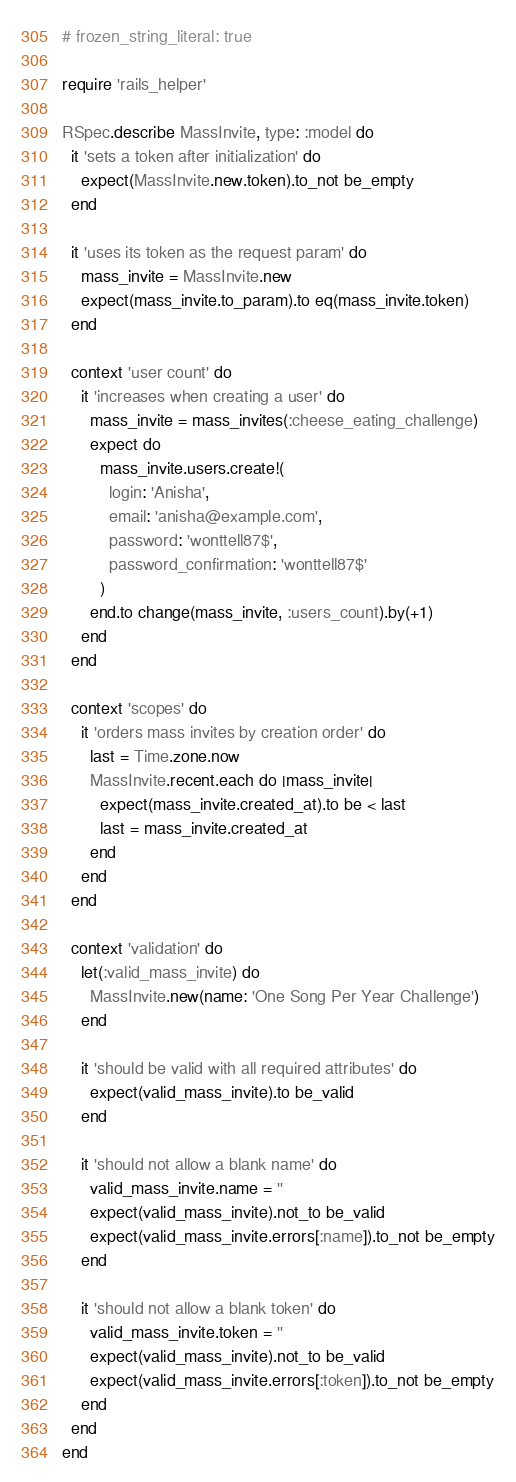Convert code to text. <code><loc_0><loc_0><loc_500><loc_500><_Ruby_># frozen_string_literal: true

require 'rails_helper'

RSpec.describe MassInvite, type: :model do
  it 'sets a token after initialization' do
    expect(MassInvite.new.token).to_not be_empty
  end

  it 'uses its token as the request param' do
    mass_invite = MassInvite.new
    expect(mass_invite.to_param).to eq(mass_invite.token)
  end

  context 'user count' do
    it 'increases when creating a user' do
      mass_invite = mass_invites(:cheese_eating_challenge)
      expect do
        mass_invite.users.create!(
          login: 'Anisha',
          email: 'anisha@example.com',
          password: 'wonttell87$',
          password_confirmation: 'wonttell87$'
        )
      end.to change(mass_invite, :users_count).by(+1)
    end
  end

  context 'scopes' do
    it 'orders mass invites by creation order' do
      last = Time.zone.now
      MassInvite.recent.each do |mass_invite|
        expect(mass_invite.created_at).to be < last
        last = mass_invite.created_at
      end
    end
  end

  context 'validation' do
    let(:valid_mass_invite) do
      MassInvite.new(name: 'One Song Per Year Challenge')
    end

    it 'should be valid with all required attributes' do
      expect(valid_mass_invite).to be_valid
    end

    it 'should not allow a blank name' do
      valid_mass_invite.name = ''
      expect(valid_mass_invite).not_to be_valid
      expect(valid_mass_invite.errors[:name]).to_not be_empty
    end

    it 'should not allow a blank token' do
      valid_mass_invite.token = ''
      expect(valid_mass_invite).not_to be_valid
      expect(valid_mass_invite.errors[:token]).to_not be_empty
    end
  end
end
</code> 